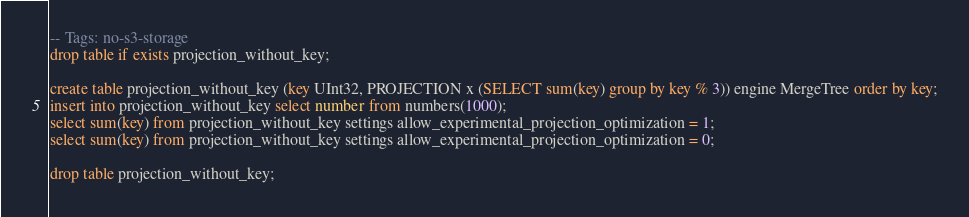Convert code to text. <code><loc_0><loc_0><loc_500><loc_500><_SQL_>-- Tags: no-s3-storage
drop table if exists projection_without_key;

create table projection_without_key (key UInt32, PROJECTION x (SELECT sum(key) group by key % 3)) engine MergeTree order by key;
insert into projection_without_key select number from numbers(1000);
select sum(key) from projection_without_key settings allow_experimental_projection_optimization = 1;
select sum(key) from projection_without_key settings allow_experimental_projection_optimization = 0;

drop table projection_without_key;
</code> 